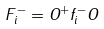Convert formula to latex. <formula><loc_0><loc_0><loc_500><loc_500>F _ { i } ^ { - } = O ^ { + } f _ { i } ^ { - } O</formula> 